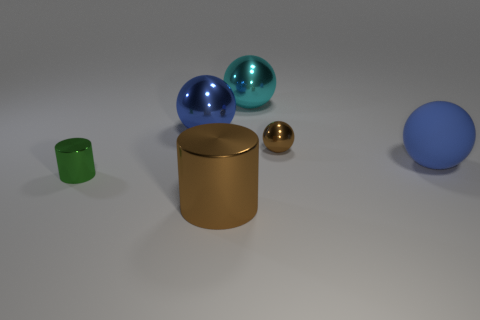There is a metal object that is in front of the blue metal thing and behind the green shiny cylinder; how big is it?
Give a very brief answer. Small. What size is the shiny sphere that is left of the brown shiny thing in front of the blue sphere to the right of the big brown cylinder?
Ensure brevity in your answer.  Large. What number of other objects are there of the same color as the big cylinder?
Provide a short and direct response. 1. Is the color of the large metal object in front of the rubber ball the same as the tiny ball?
Provide a short and direct response. Yes. How many things are either green metal cylinders or blue metal spheres?
Offer a very short reply. 2. There is a metallic cylinder that is to the left of the large shiny cylinder; what color is it?
Your answer should be compact. Green. Is the number of big cyan balls that are to the left of the brown cylinder less than the number of big metal objects?
Your response must be concise. Yes. There is a metallic object that is the same color as the rubber ball; what size is it?
Offer a terse response. Large. Does the large cyan ball have the same material as the tiny brown thing?
Your response must be concise. Yes. How many objects are cyan things to the left of the big blue rubber thing or big metallic objects that are in front of the cyan sphere?
Provide a succinct answer. 3. 